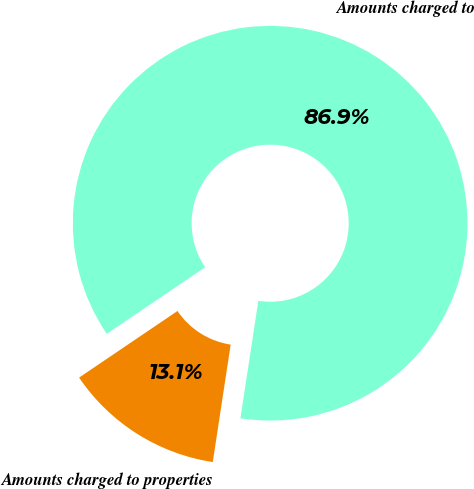Convert chart to OTSL. <chart><loc_0><loc_0><loc_500><loc_500><pie_chart><fcel>Amounts charged to<fcel>Amounts charged to properties<nl><fcel>86.88%<fcel>13.12%<nl></chart> 